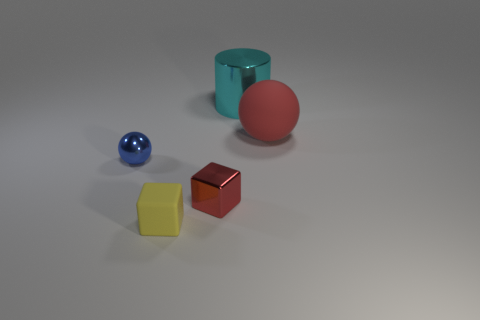There is a matte thing behind the shiny cube; is its color the same as the shiny block?
Your answer should be very brief. Yes. What is the material of the ball to the left of the big thing behind the red thing that is to the right of the cyan cylinder?
Keep it short and to the point. Metal. Are the tiny red cube and the cyan thing made of the same material?
Provide a short and direct response. Yes. What number of spheres are either large shiny things or blue objects?
Keep it short and to the point. 1. The small cube that is on the right side of the yellow rubber block is what color?
Offer a terse response. Red. What number of shiny things are big cylinders or small gray objects?
Your answer should be compact. 1. There is a small blue object behind the metal thing that is in front of the blue shiny thing; what is it made of?
Make the answer very short. Metal. There is a small cube that is the same color as the big rubber ball; what is it made of?
Keep it short and to the point. Metal. What is the color of the matte ball?
Your answer should be very brief. Red. There is a red thing that is on the right side of the cyan metallic cylinder; is there a tiny shiny block left of it?
Keep it short and to the point. Yes. 